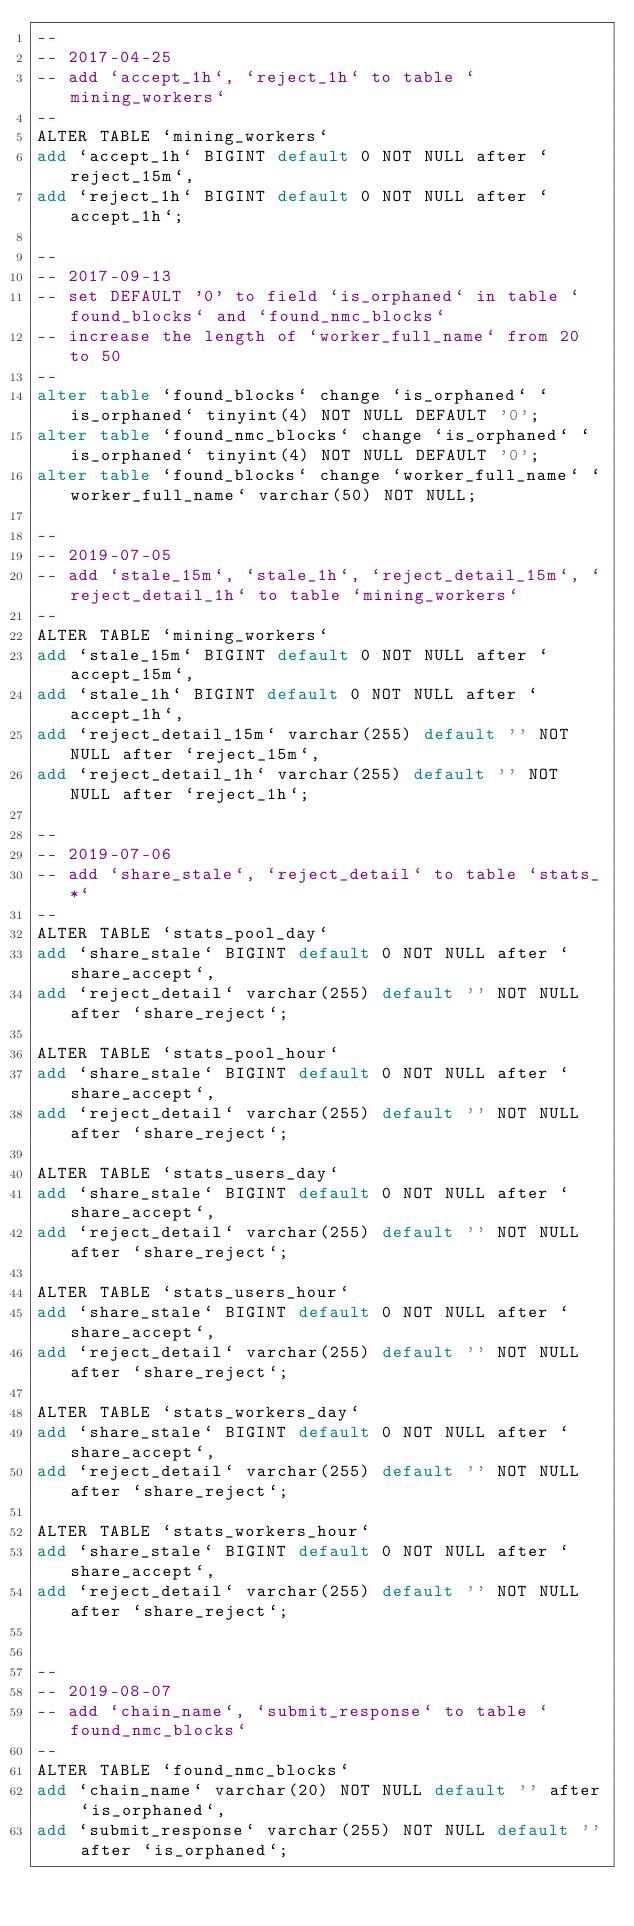Convert code to text. <code><loc_0><loc_0><loc_500><loc_500><_SQL_>--
-- 2017-04-25
-- add `accept_1h`, `reject_1h` to table `mining_workers`
--
ALTER TABLE `mining_workers`
add `accept_1h` BIGINT default 0 NOT NULL after `reject_15m`,
add `reject_1h` BIGINT default 0 NOT NULL after `accept_1h`;

--
-- 2017-09-13
-- set DEFAULT '0' to field `is_orphaned` in table `found_blocks` and `found_nmc_blocks`
-- increase the length of `worker_full_name` from 20 to 50
--
alter table `found_blocks` change `is_orphaned` `is_orphaned` tinyint(4) NOT NULL DEFAULT '0';
alter table `found_nmc_blocks` change `is_orphaned` `is_orphaned` tinyint(4) NOT NULL DEFAULT '0';
alter table `found_blocks` change `worker_full_name` `worker_full_name` varchar(50) NOT NULL;

--
-- 2019-07-05
-- add `stale_15m`, `stale_1h`, `reject_detail_15m`, `reject_detail_1h` to table `mining_workers`
--
ALTER TABLE `mining_workers`
add `stale_15m` BIGINT default 0 NOT NULL after `accept_15m`,
add `stale_1h` BIGINT default 0 NOT NULL after `accept_1h`,
add `reject_detail_15m` varchar(255) default '' NOT NULL after `reject_15m`,
add `reject_detail_1h` varchar(255) default '' NOT NULL after `reject_1h`;

--
-- 2019-07-06
-- add `share_stale`, `reject_detail` to table `stats_*`
--
ALTER TABLE `stats_pool_day`
add `share_stale` BIGINT default 0 NOT NULL after `share_accept`,
add `reject_detail` varchar(255) default '' NOT NULL after `share_reject`;

ALTER TABLE `stats_pool_hour`
add `share_stale` BIGINT default 0 NOT NULL after `share_accept`,
add `reject_detail` varchar(255) default '' NOT NULL after `share_reject`;

ALTER TABLE `stats_users_day`
add `share_stale` BIGINT default 0 NOT NULL after `share_accept`,
add `reject_detail` varchar(255) default '' NOT NULL after `share_reject`;

ALTER TABLE `stats_users_hour`
add `share_stale` BIGINT default 0 NOT NULL after `share_accept`,
add `reject_detail` varchar(255) default '' NOT NULL after `share_reject`;

ALTER TABLE `stats_workers_day`
add `share_stale` BIGINT default 0 NOT NULL after `share_accept`,
add `reject_detail` varchar(255) default '' NOT NULL after `share_reject`;

ALTER TABLE `stats_workers_hour`
add `share_stale` BIGINT default 0 NOT NULL after `share_accept`,
add `reject_detail` varchar(255) default '' NOT NULL after `share_reject`;


--
-- 2019-08-07
-- add `chain_name`, `submit_response` to table `found_nmc_blocks`
--
ALTER TABLE `found_nmc_blocks`
add `chain_name` varchar(20) NOT NULL default '' after `is_orphaned`,
add `submit_response` varchar(255) NOT NULL default '' after `is_orphaned`;
</code> 